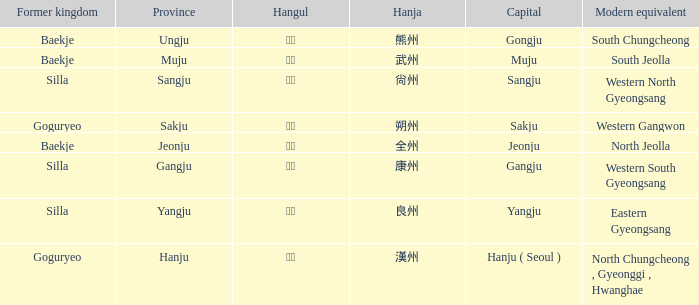What is the hanja representation for the "sangju" province? 尙州. 